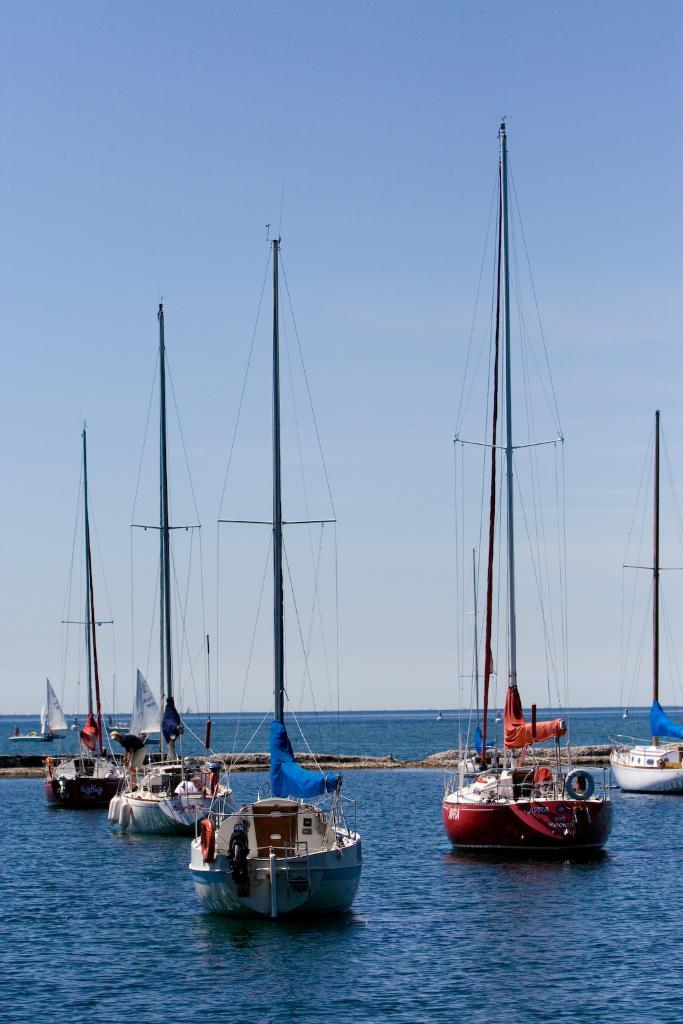What can be seen on the surface of the water in the image? There are ships on the surface of the water in the image. What color is the sky in the image? The sky is blue in the image. What type of mark is visible on the tail of the ship in the image? There is no tail on the ships in the image, as they are not animals or have any visible tails. 